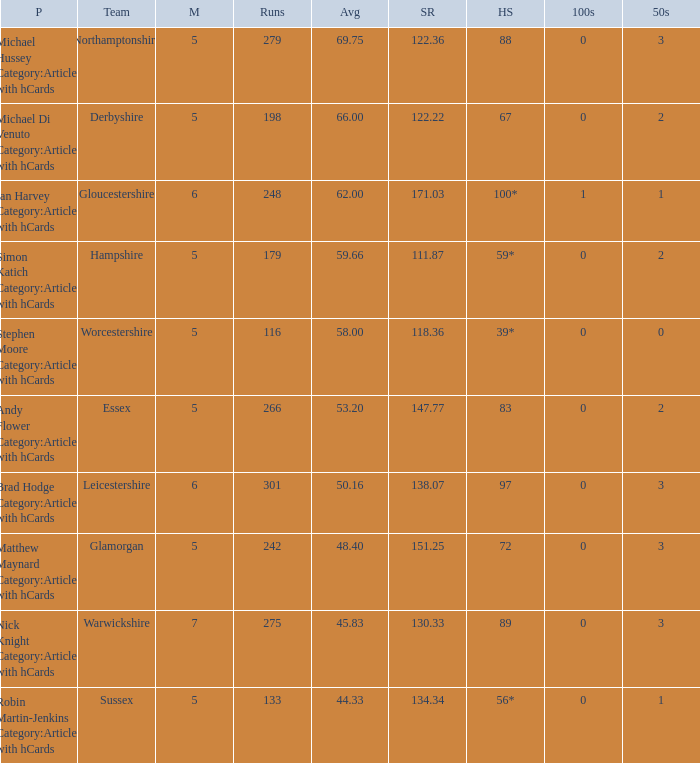If the team is Worcestershire and the Matched had were 5, what is the highest score? 39*. 